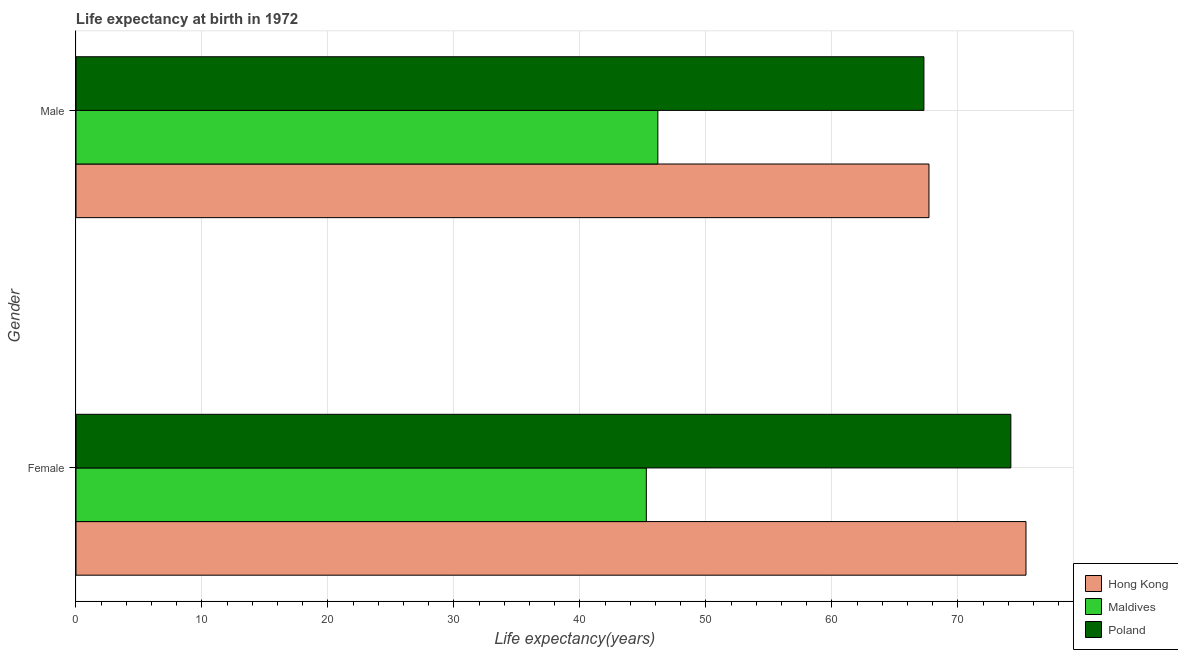Are the number of bars per tick equal to the number of legend labels?
Offer a very short reply. Yes. What is the label of the 1st group of bars from the top?
Offer a very short reply. Male. What is the life expectancy(male) in Poland?
Keep it short and to the point. 67.3. Across all countries, what is the maximum life expectancy(male)?
Provide a succinct answer. 67.7. Across all countries, what is the minimum life expectancy(female)?
Your answer should be very brief. 45.27. In which country was the life expectancy(male) maximum?
Provide a succinct answer. Hong Kong. In which country was the life expectancy(male) minimum?
Your answer should be very brief. Maldives. What is the total life expectancy(female) in the graph?
Provide a short and direct response. 194.87. What is the difference between the life expectancy(female) in Maldives and that in Hong Kong?
Your answer should be very brief. -30.13. What is the difference between the life expectancy(male) in Hong Kong and the life expectancy(female) in Maldives?
Give a very brief answer. 22.43. What is the average life expectancy(male) per country?
Your response must be concise. 60.39. What is the difference between the life expectancy(female) and life expectancy(male) in Poland?
Provide a succinct answer. 6.9. What is the ratio of the life expectancy(male) in Hong Kong to that in Poland?
Offer a terse response. 1.01. Is the life expectancy(male) in Poland less than that in Maldives?
Provide a succinct answer. No. In how many countries, is the life expectancy(male) greater than the average life expectancy(male) taken over all countries?
Provide a short and direct response. 2. What does the 3rd bar from the top in Male represents?
Offer a terse response. Hong Kong. What does the 2nd bar from the bottom in Male represents?
Your answer should be very brief. Maldives. How many bars are there?
Offer a terse response. 6. Are all the bars in the graph horizontal?
Your response must be concise. Yes. Are the values on the major ticks of X-axis written in scientific E-notation?
Ensure brevity in your answer.  No. Does the graph contain any zero values?
Provide a short and direct response. No. Does the graph contain grids?
Provide a short and direct response. Yes. Where does the legend appear in the graph?
Give a very brief answer. Bottom right. What is the title of the graph?
Keep it short and to the point. Life expectancy at birth in 1972. What is the label or title of the X-axis?
Your response must be concise. Life expectancy(years). What is the label or title of the Y-axis?
Keep it short and to the point. Gender. What is the Life expectancy(years) in Hong Kong in Female?
Make the answer very short. 75.4. What is the Life expectancy(years) of Maldives in Female?
Your answer should be compact. 45.27. What is the Life expectancy(years) in Poland in Female?
Keep it short and to the point. 74.2. What is the Life expectancy(years) of Hong Kong in Male?
Your answer should be compact. 67.7. What is the Life expectancy(years) in Maldives in Male?
Your answer should be very brief. 46.18. What is the Life expectancy(years) in Poland in Male?
Provide a succinct answer. 67.3. Across all Gender, what is the maximum Life expectancy(years) of Hong Kong?
Ensure brevity in your answer.  75.4. Across all Gender, what is the maximum Life expectancy(years) of Maldives?
Provide a succinct answer. 46.18. Across all Gender, what is the maximum Life expectancy(years) in Poland?
Offer a terse response. 74.2. Across all Gender, what is the minimum Life expectancy(years) in Hong Kong?
Offer a very short reply. 67.7. Across all Gender, what is the minimum Life expectancy(years) in Maldives?
Ensure brevity in your answer.  45.27. Across all Gender, what is the minimum Life expectancy(years) in Poland?
Provide a succinct answer. 67.3. What is the total Life expectancy(years) in Hong Kong in the graph?
Make the answer very short. 143.1. What is the total Life expectancy(years) in Maldives in the graph?
Provide a short and direct response. 91.45. What is the total Life expectancy(years) of Poland in the graph?
Make the answer very short. 141.5. What is the difference between the Life expectancy(years) of Maldives in Female and that in Male?
Give a very brief answer. -0.91. What is the difference between the Life expectancy(years) in Poland in Female and that in Male?
Provide a short and direct response. 6.9. What is the difference between the Life expectancy(years) in Hong Kong in Female and the Life expectancy(years) in Maldives in Male?
Keep it short and to the point. 29.22. What is the difference between the Life expectancy(years) in Hong Kong in Female and the Life expectancy(years) in Poland in Male?
Ensure brevity in your answer.  8.1. What is the difference between the Life expectancy(years) of Maldives in Female and the Life expectancy(years) of Poland in Male?
Make the answer very short. -22.03. What is the average Life expectancy(years) in Hong Kong per Gender?
Make the answer very short. 71.55. What is the average Life expectancy(years) in Maldives per Gender?
Provide a succinct answer. 45.73. What is the average Life expectancy(years) of Poland per Gender?
Keep it short and to the point. 70.75. What is the difference between the Life expectancy(years) of Hong Kong and Life expectancy(years) of Maldives in Female?
Provide a short and direct response. 30.13. What is the difference between the Life expectancy(years) in Hong Kong and Life expectancy(years) in Poland in Female?
Make the answer very short. 1.2. What is the difference between the Life expectancy(years) of Maldives and Life expectancy(years) of Poland in Female?
Your response must be concise. -28.93. What is the difference between the Life expectancy(years) in Hong Kong and Life expectancy(years) in Maldives in Male?
Your response must be concise. 21.52. What is the difference between the Life expectancy(years) of Hong Kong and Life expectancy(years) of Poland in Male?
Provide a short and direct response. 0.4. What is the difference between the Life expectancy(years) of Maldives and Life expectancy(years) of Poland in Male?
Provide a short and direct response. -21.12. What is the ratio of the Life expectancy(years) in Hong Kong in Female to that in Male?
Your answer should be very brief. 1.11. What is the ratio of the Life expectancy(years) in Maldives in Female to that in Male?
Give a very brief answer. 0.98. What is the ratio of the Life expectancy(years) of Poland in Female to that in Male?
Provide a succinct answer. 1.1. What is the difference between the highest and the second highest Life expectancy(years) of Hong Kong?
Give a very brief answer. 7.7. What is the difference between the highest and the second highest Life expectancy(years) of Maldives?
Offer a terse response. 0.91. What is the difference between the highest and the lowest Life expectancy(years) in Maldives?
Provide a short and direct response. 0.91. 